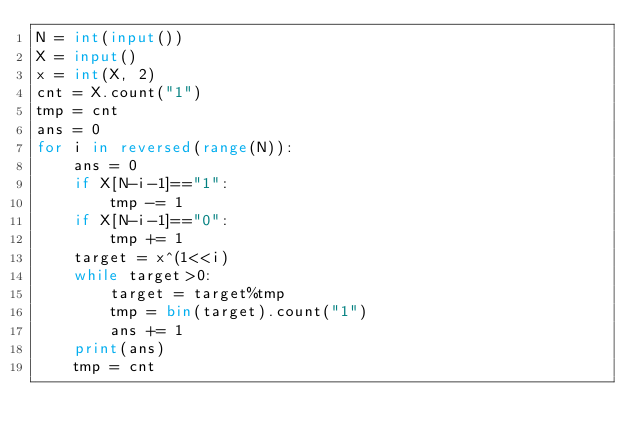Convert code to text. <code><loc_0><loc_0><loc_500><loc_500><_Python_>N = int(input())
X = input()
x = int(X, 2)
cnt = X.count("1")
tmp = cnt
ans = 0
for i in reversed(range(N)):
    ans = 0
    if X[N-i-1]=="1":
        tmp -= 1
    if X[N-i-1]=="0":
        tmp += 1
    target = x^(1<<i)
    while target>0:
        target = target%tmp
        tmp = bin(target).count("1")
        ans += 1
    print(ans)
    tmp = cnt</code> 